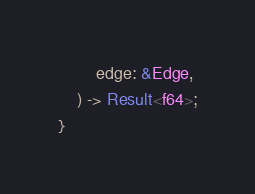<code> <loc_0><loc_0><loc_500><loc_500><_Rust_>        edge: &Edge,
    ) -> Result<f64>;
}
</code> 